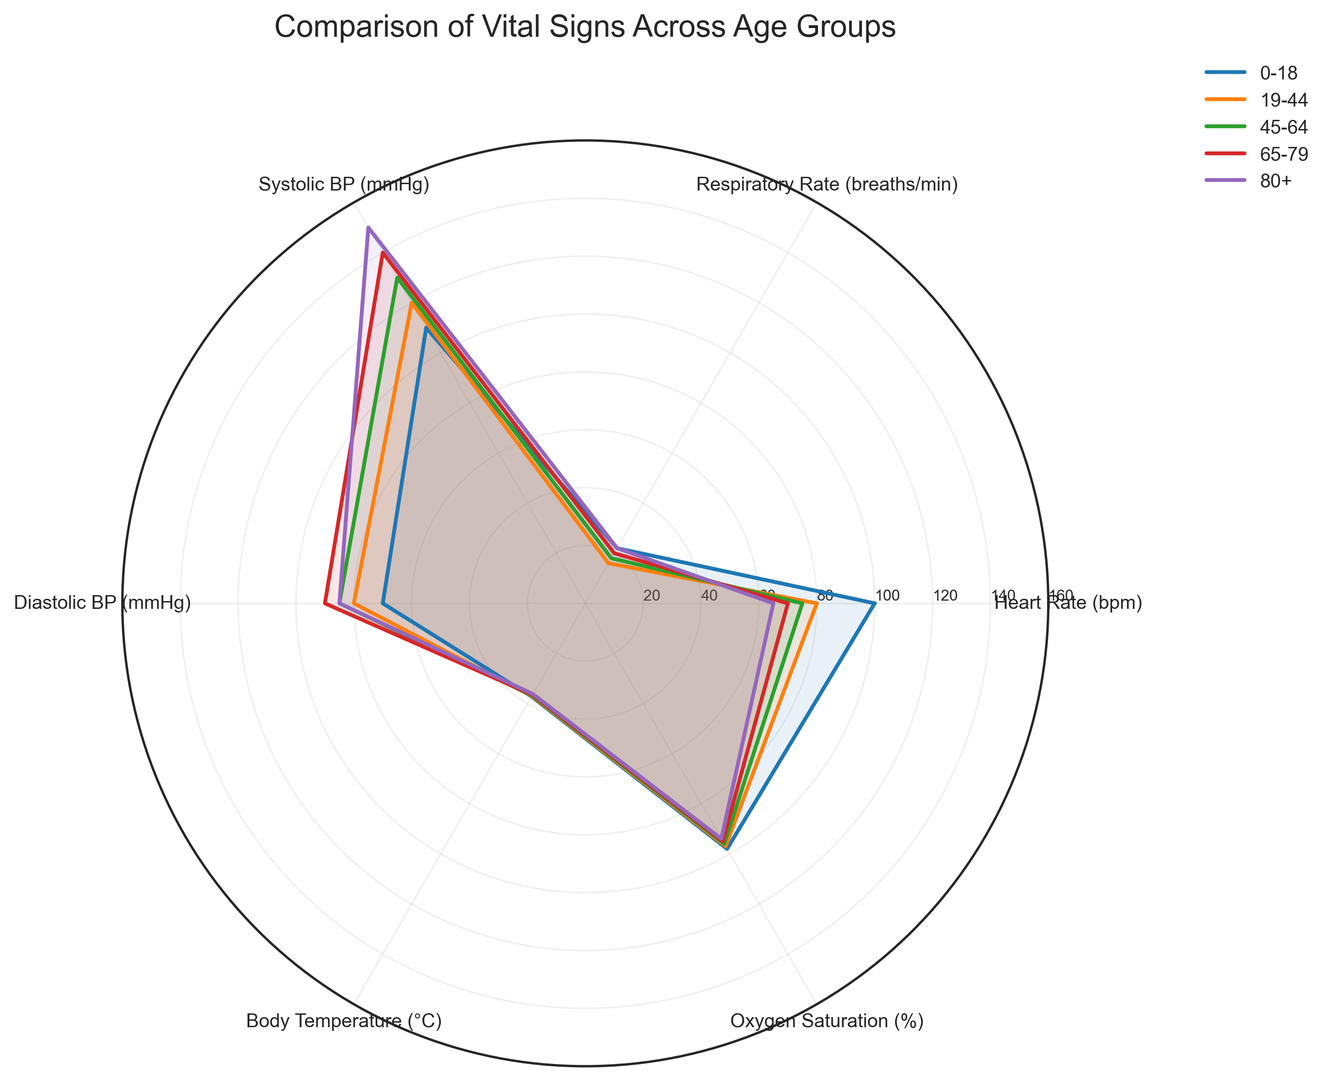Which age group has the lowest heart rate? The radar chart indicates that the age group with the lowest heart rate is represented by the smallest value on the heart rate axis. The 80+ age group is shown to have the lowest heart rate, which is around 65 bpm.
Answer: 80+ Which two age groups have the same respiratory rate? By looking at the respiratory rate axis in the chart, one can observe that the 0-18 and 80+ age groups both have values of 22 breaths/min, indicated by the same point along the respiratory rate axis for these two groups.
Answer: 0-18 and 80+ How does the systolic blood pressure of the 65-79 age group compare to that of the 19-44 age group? The radar chart shows that the 65-79 age group has a systolic blood pressure of 140 mmHg, while the 19-44 age group has a systolic blood pressure of 120 mmHg. Thus, the 65-79 age group has a higher systolic blood pressure by 20 mmHg.
Answer: 65-79 age group has higher systolic blood pressure What is the average body temperature across all age groups? The body temperatures for all age groups are 37.2, 37.0, 36.8, 36.5, and 36.2 °C. Summing these values gives 183.7 °C, and dividing by the 5 age groups gives the average body temperature: 183.7 / 5 = 36.74 °C.
Answer: 36.74 °C Which vital sign has the greatest variation among different age groups? By observing the spread of values across all vital signs in the radar chart, it is clear that systolic blood pressure has the widest range, from 110 mmHg in the 0-18 age group to 150 mmHg in the 80+ age group. This indicates the greatest variation among the data points.
Answer: Systolic blood pressure Between the 45-64 and 65-79 age groups, which group has a higher oxygen saturation level? By examining the radar chart, the oxygen saturation level for the 45-64 age group is 96% and for the 65-79 age group it is 95%. Thus, the 45-64 age group has a higher oxygen saturation level.
Answer: 45-64 age group 